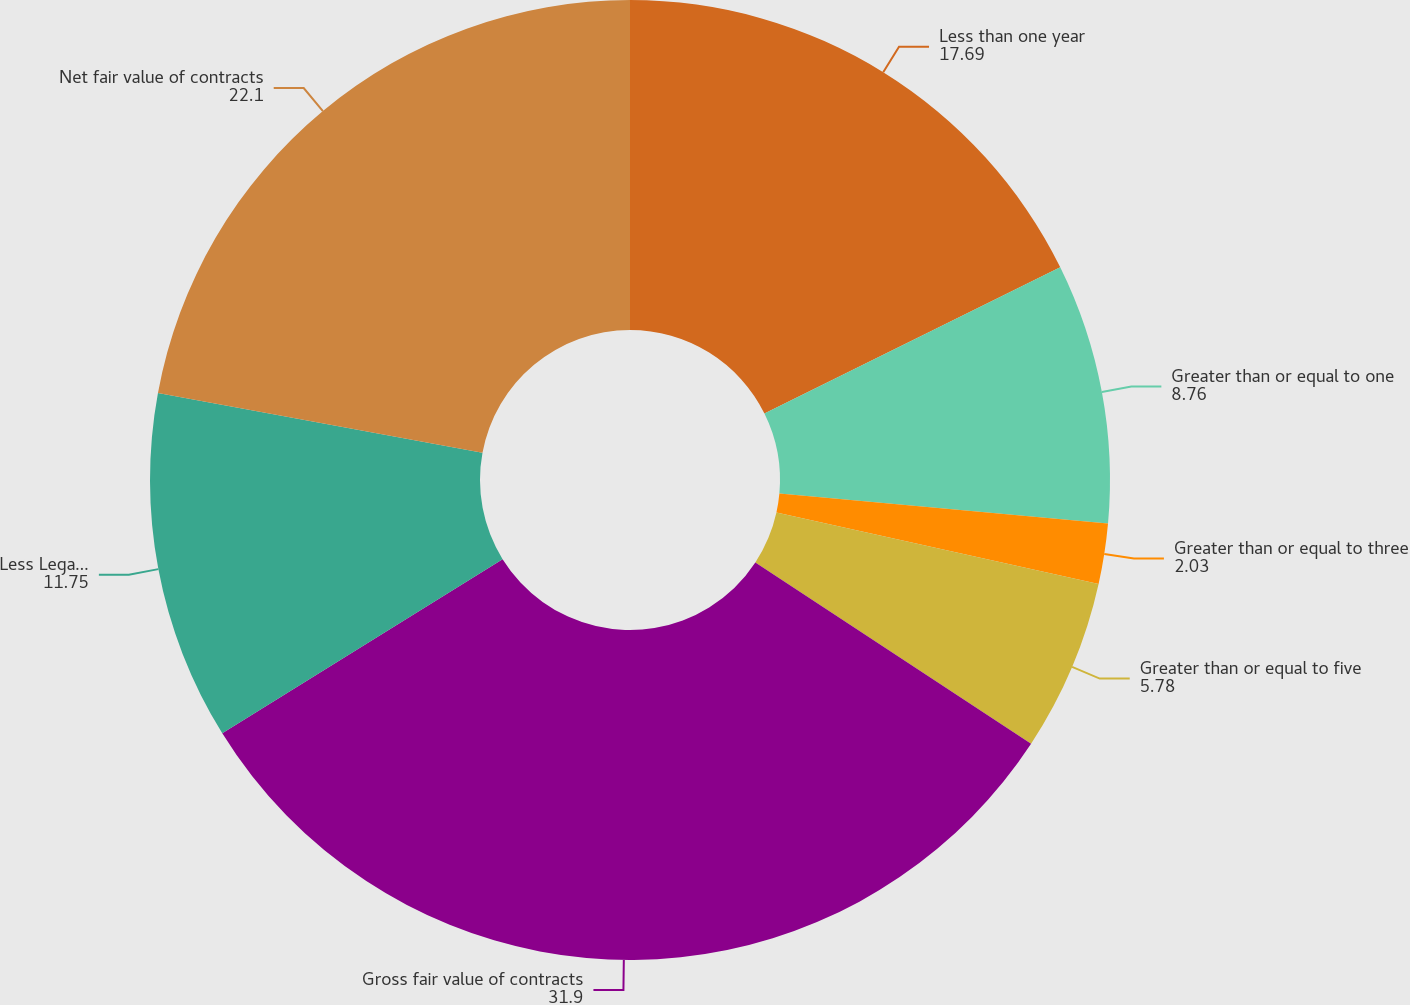<chart> <loc_0><loc_0><loc_500><loc_500><pie_chart><fcel>Less than one year<fcel>Greater than or equal to one<fcel>Greater than or equal to three<fcel>Greater than or equal to five<fcel>Gross fair value of contracts<fcel>Less Legally enforceable<fcel>Net fair value of contracts<nl><fcel>17.69%<fcel>8.76%<fcel>2.03%<fcel>5.78%<fcel>31.9%<fcel>11.75%<fcel>22.1%<nl></chart> 